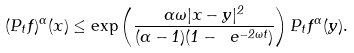Convert formula to latex. <formula><loc_0><loc_0><loc_500><loc_500>( P _ { t } f ) ^ { \alpha } ( x ) \leq \exp \left ( \frac { \alpha \omega | x - y | ^ { 2 } } { ( \alpha - 1 ) ( 1 - \ e ^ { - 2 \omega t } ) } \right ) P _ { t } f ^ { \alpha } ( y ) .</formula> 